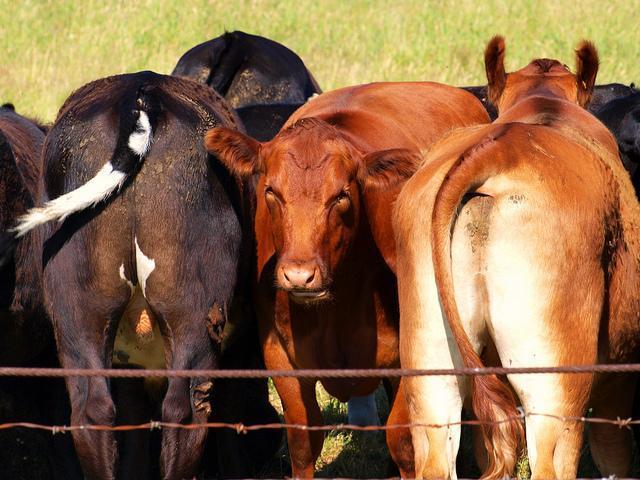How many cows are facing the camera?
Give a very brief answer. 1. How many cows can you see?
Give a very brief answer. 6. 